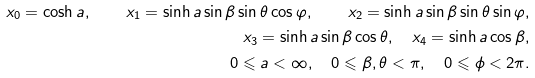<formula> <loc_0><loc_0><loc_500><loc_500>x _ { 0 } = \cosh a , \quad x _ { 1 } = \sinh a \sin \beta \sin \theta \cos \varphi , \quad x _ { 2 } = \sinh a \sin \beta \sin \theta \sin \varphi , \\ x _ { 3 } = \sinh a \sin \beta \cos \theta , \quad x _ { 4 } = \sinh a \cos \beta , \\ 0 \leqslant a < \infty , \quad 0 \leqslant \beta , \theta < \pi , \quad 0 \leqslant \phi < 2 \pi .</formula> 